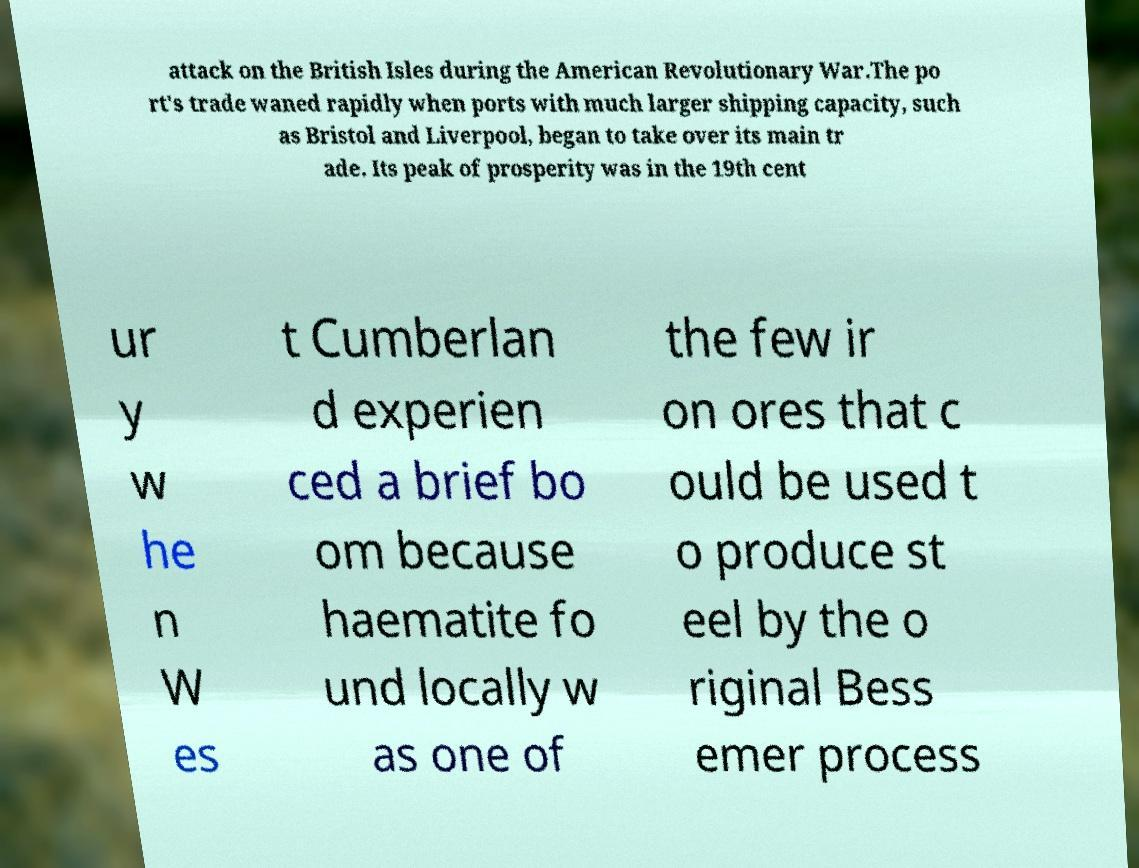Can you read and provide the text displayed in the image?This photo seems to have some interesting text. Can you extract and type it out for me? attack on the British Isles during the American Revolutionary War.The po rt's trade waned rapidly when ports with much larger shipping capacity, such as Bristol and Liverpool, began to take over its main tr ade. Its peak of prosperity was in the 19th cent ur y w he n W es t Cumberlan d experien ced a brief bo om because haematite fo und locally w as one of the few ir on ores that c ould be used t o produce st eel by the o riginal Bess emer process 